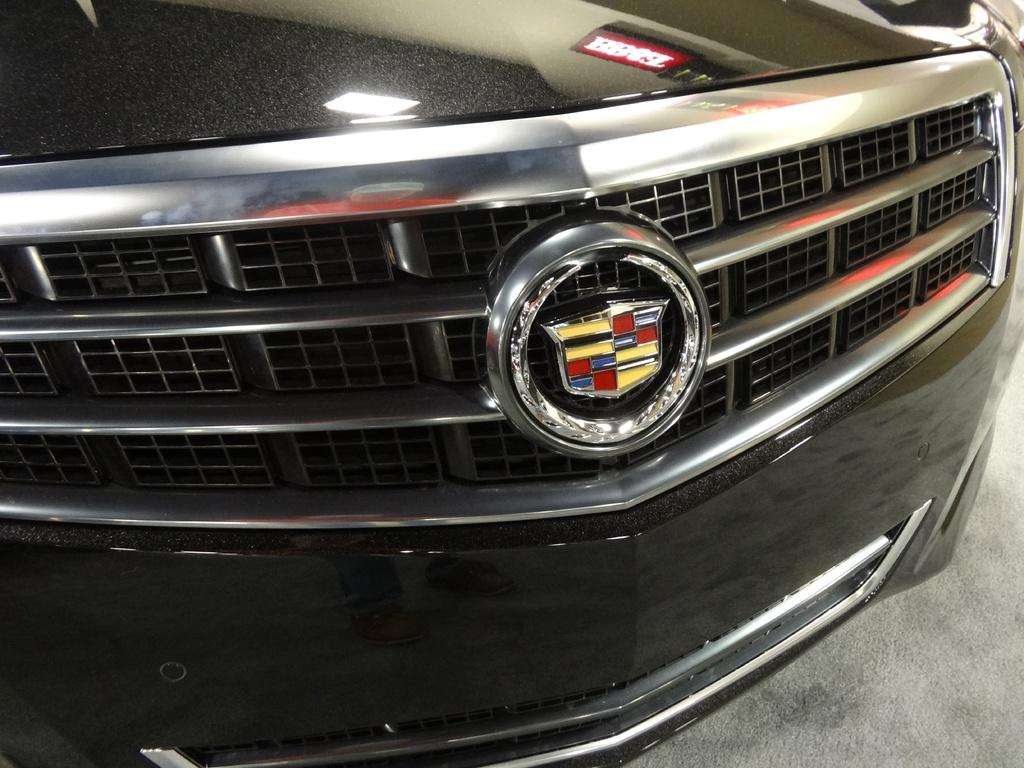What color is the car in the image? The car in the image is black. Can you describe any specific features of the car? There is a logo in the middle of the car. How many houses are visible in the image? There are no houses visible in the image; it only features a black car with a logo in the middle. 